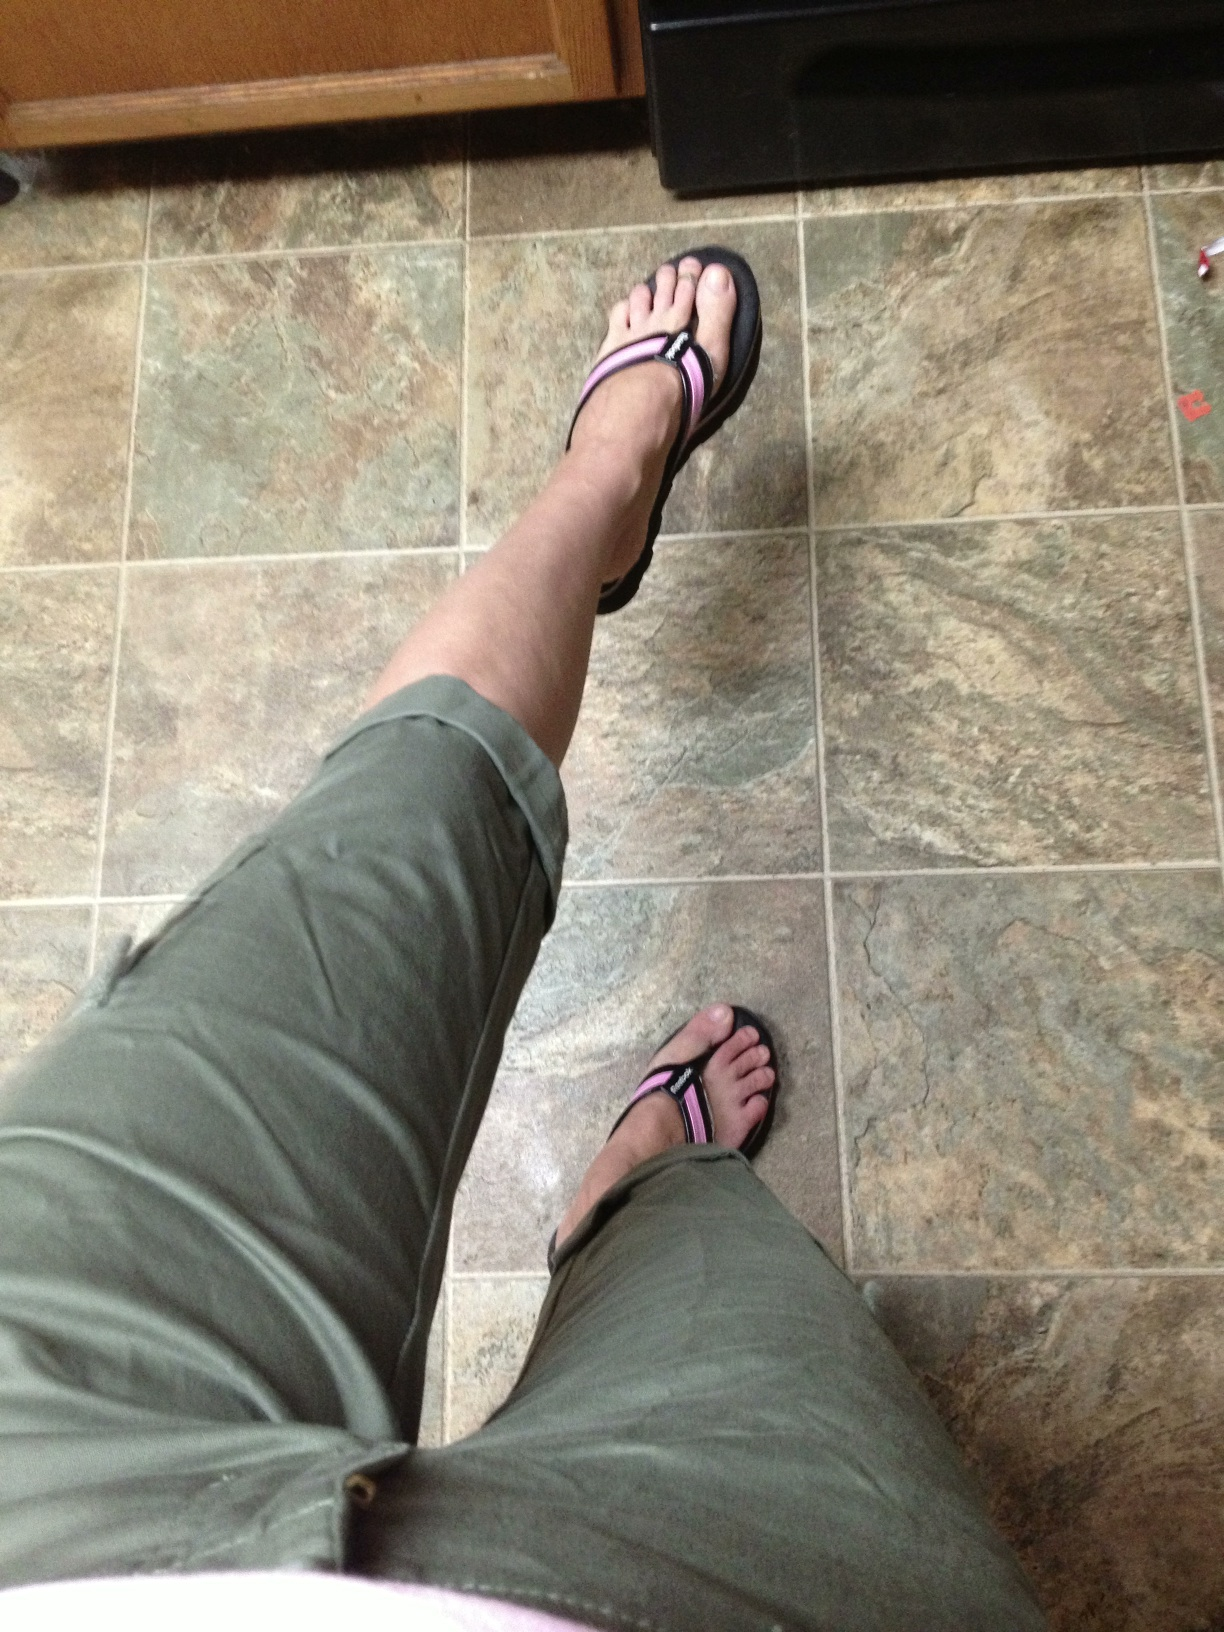What type of shoes am I wearing in this picture? You are wearing flip-flops with a black sole and pink straps. They seem to be comfortable for casual wear. 